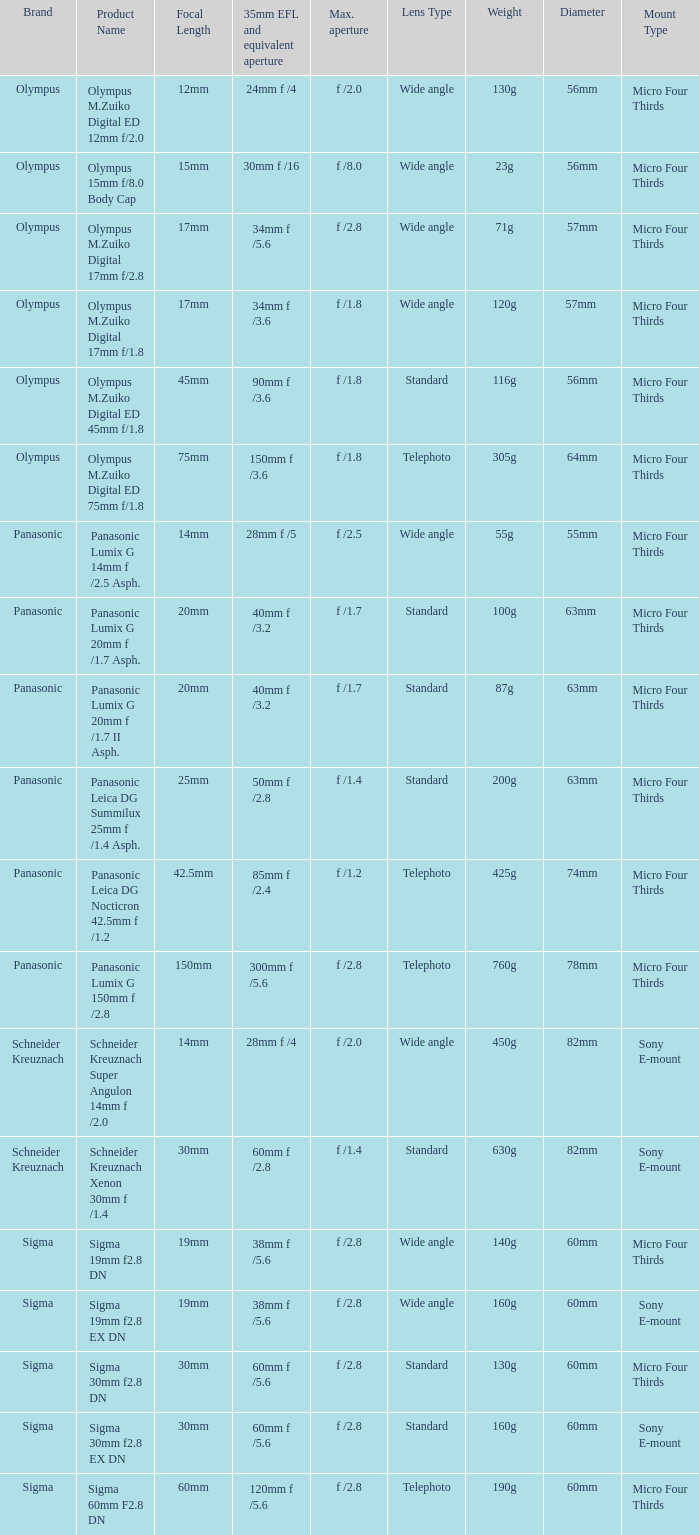What is the 35mm EFL and the equivalent aperture of the lens(es) with a maximum aperture of f /2.5? 28mm f /5. 